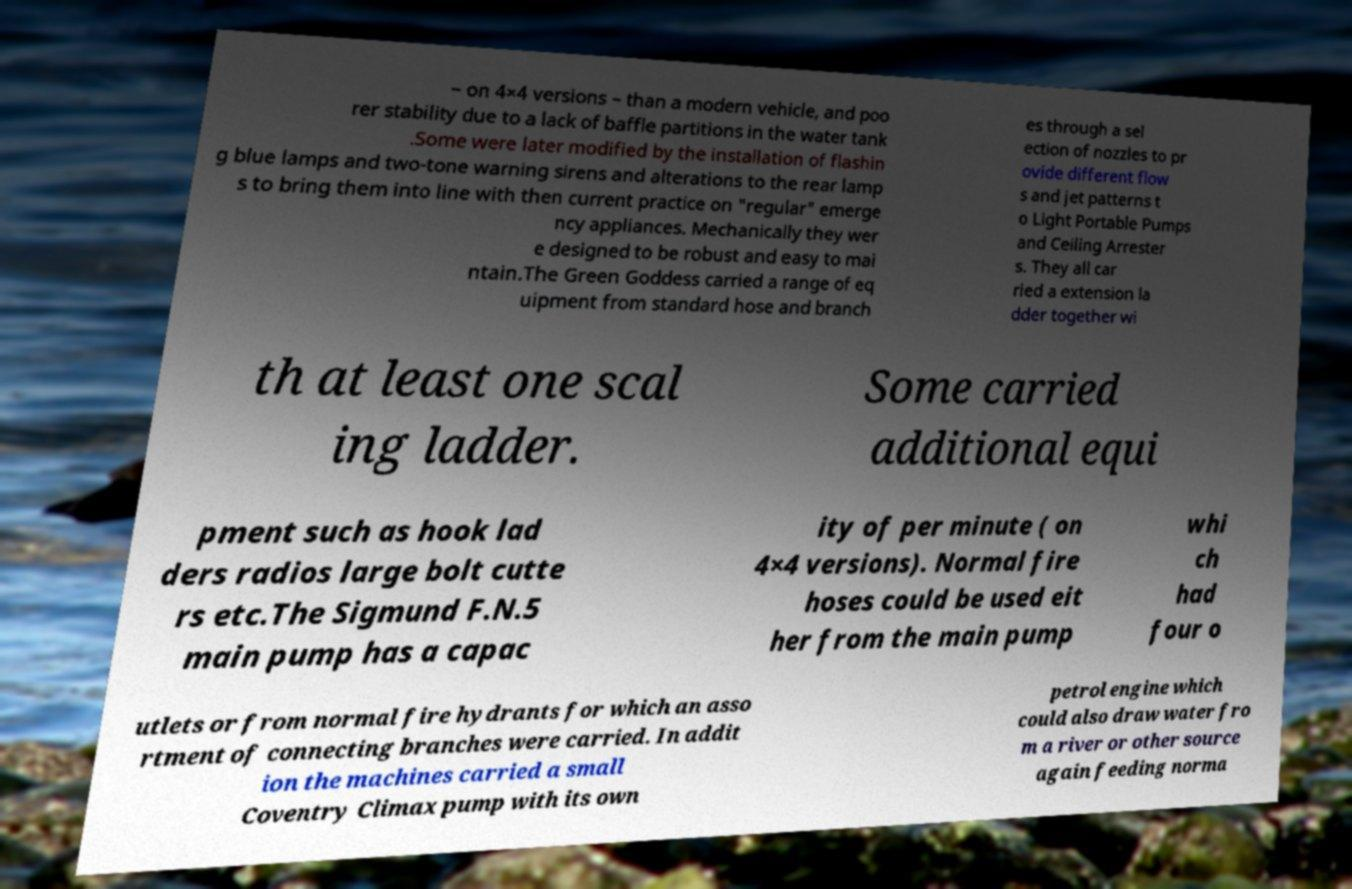Please identify and transcribe the text found in this image. – on 4×4 versions – than a modern vehicle, and poo rer stability due to a lack of baffle partitions in the water tank .Some were later modified by the installation of flashin g blue lamps and two-tone warning sirens and alterations to the rear lamp s to bring them into line with then current practice on "regular" emerge ncy appliances. Mechanically they wer e designed to be robust and easy to mai ntain.The Green Goddess carried a range of eq uipment from standard hose and branch es through a sel ection of nozzles to pr ovide different flow s and jet patterns t o Light Portable Pumps and Ceiling Arrester s. They all car ried a extension la dder together wi th at least one scal ing ladder. Some carried additional equi pment such as hook lad ders radios large bolt cutte rs etc.The Sigmund F.N.5 main pump has a capac ity of per minute ( on 4×4 versions). Normal fire hoses could be used eit her from the main pump whi ch had four o utlets or from normal fire hydrants for which an asso rtment of connecting branches were carried. In addit ion the machines carried a small Coventry Climax pump with its own petrol engine which could also draw water fro m a river or other source again feeding norma 